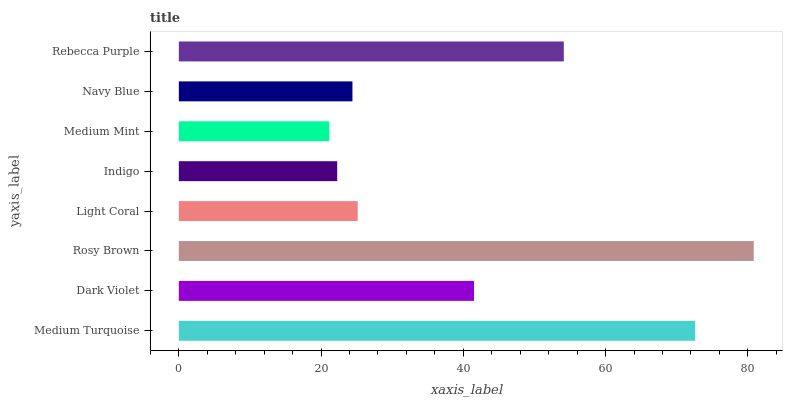Is Medium Mint the minimum?
Answer yes or no. Yes. Is Rosy Brown the maximum?
Answer yes or no. Yes. Is Dark Violet the minimum?
Answer yes or no. No. Is Dark Violet the maximum?
Answer yes or no. No. Is Medium Turquoise greater than Dark Violet?
Answer yes or no. Yes. Is Dark Violet less than Medium Turquoise?
Answer yes or no. Yes. Is Dark Violet greater than Medium Turquoise?
Answer yes or no. No. Is Medium Turquoise less than Dark Violet?
Answer yes or no. No. Is Dark Violet the high median?
Answer yes or no. Yes. Is Light Coral the low median?
Answer yes or no. Yes. Is Indigo the high median?
Answer yes or no. No. Is Medium Turquoise the low median?
Answer yes or no. No. 